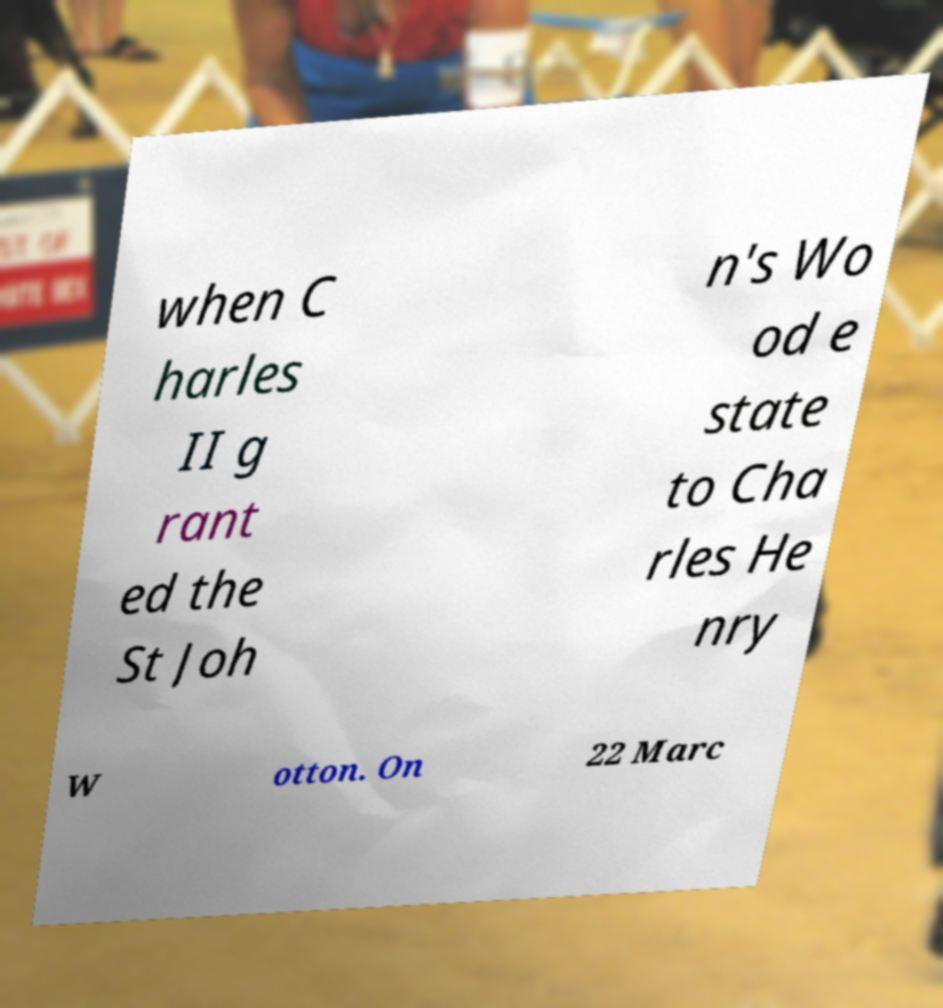Could you extract and type out the text from this image? when C harles II g rant ed the St Joh n's Wo od e state to Cha rles He nry W otton. On 22 Marc 